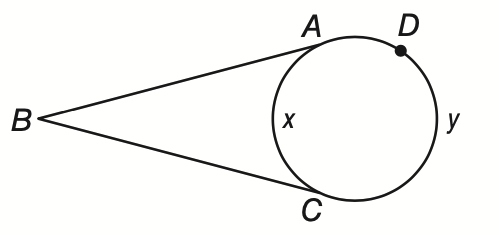Answer the mathemtical geometry problem and directly provide the correct option letter.
Question: The degree measure of minor arc \widehat A C and major arc \widehat A D C are x and y respectively. If m \angle A B C = 70, find y.
Choices: A: 110 B: 180 C: 250 D: 270 C 